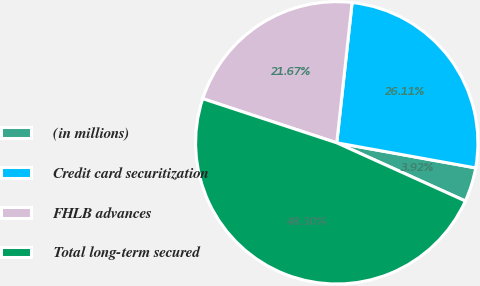Convert chart to OTSL. <chart><loc_0><loc_0><loc_500><loc_500><pie_chart><fcel>(in millions)<fcel>Credit card securitization<fcel>FHLB advances<fcel>Total long-term secured<nl><fcel>3.92%<fcel>26.11%<fcel>21.67%<fcel>48.3%<nl></chart> 